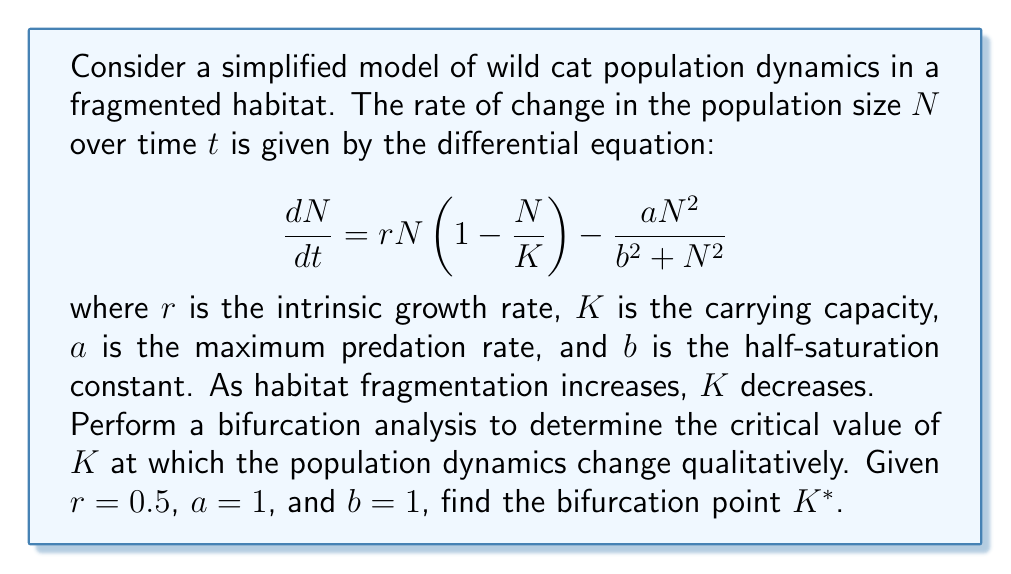Can you solve this math problem? To perform a bifurcation analysis, we need to follow these steps:

1) First, find the equilibrium points by setting $\frac{dN}{dt} = 0$:

   $$0 = rN(1-\frac{N}{K}) - \frac{aN^2}{b^2 + N^2}$$

2) Rearrange the equation:

   $$rN(1-\frac{N}{K}) = \frac{aN^2}{b^2 + N^2}$$

3) Multiply both sides by $(b^2 + N^2)$:

   $$rN(1-\frac{N}{K})(b^2 + N^2) = aN^2$$

4) Expand:

   $$rNb^2 + rN^3 - \frac{rNb^2}{K} - \frac{rN^3}{K} = aN^2$$

5) Rearrange to get a cubic equation:

   $$rN^3 - \frac{rN^3}{K} - aN^2 + rNb^2 - \frac{rNb^2}{K} = 0$$

6) Simplify:

   $$N^3(r - \frac{r}{K}) - aN^2 + Nb^2(r - \frac{r}{K}) = 0$$

7) The bifurcation point occurs when this cubic equation has a double root. This happens when the discriminant of the cubic equation is zero.

8) For a cubic equation $ax^3 + bx^2 + cx + d = 0$, the discriminant is:

   $$\Delta = 18abcd - 4b^3d + b^2c^2 - 4ac^3 - 27a^2d^2$$

9) In our case:
   $a = r - \frac{r}{K}$
   $b = -a$
   $c = b^2(r - \frac{r}{K})$
   $d = 0$

10) Substituting these into the discriminant formula and setting it to zero:

    $$4a^3c + 27a^2d^2 - b^2c^2 + 4b^3d - 18abcd = 0$$

11) Simplify, given $d=0$:

    $$4a^3c - b^2c^2 = 0$$

12) Substitute the values:

    $$4(r - \frac{r}{K})^3b^2(r - \frac{r}{K}) - a^2(b^2(r - \frac{r}{K}))^2 = 0$$

13) Simplify:

    $$4(r - \frac{r}{K})^4b^2 - a^2b^4(r - \frac{r}{K})^2 = 0$$

14) Substitute the given values $r=0.5$, $a=1$, $b=1$:

    $$4(0.5 - \frac{0.5}{K})^4 - (0.5 - \frac{0.5}{K})^2 = 0$$

15) Solve this equation numerically to find $K^*$.

Using a numerical solver, we find that $K^* \approx 1.0718$.
Answer: $K^* \approx 1.0718$ 